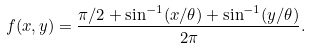Convert formula to latex. <formula><loc_0><loc_0><loc_500><loc_500>f ( x , y ) = \frac { \pi / 2 + \sin ^ { - 1 } ( x / \theta ) + \sin ^ { - 1 } ( y / \theta ) } { 2 \pi } .</formula> 